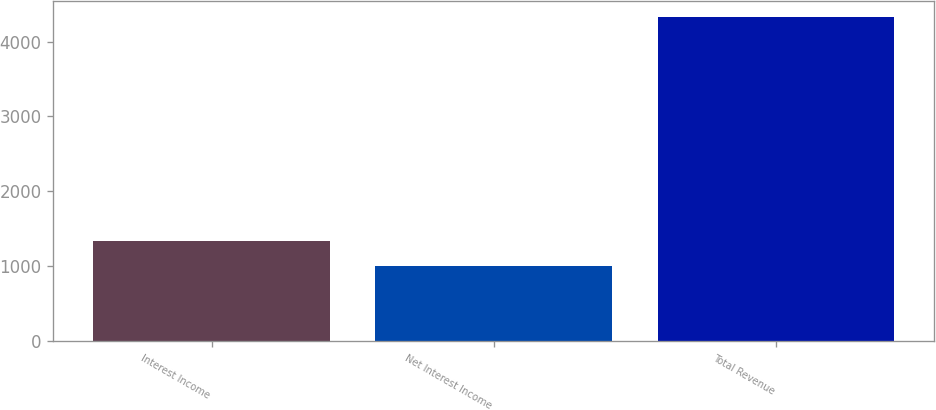Convert chart. <chart><loc_0><loc_0><loc_500><loc_500><bar_chart><fcel>Interest Income<fcel>Net Interest Income<fcel>Total Revenue<nl><fcel>1338.07<fcel>1005.5<fcel>4331.2<nl></chart> 